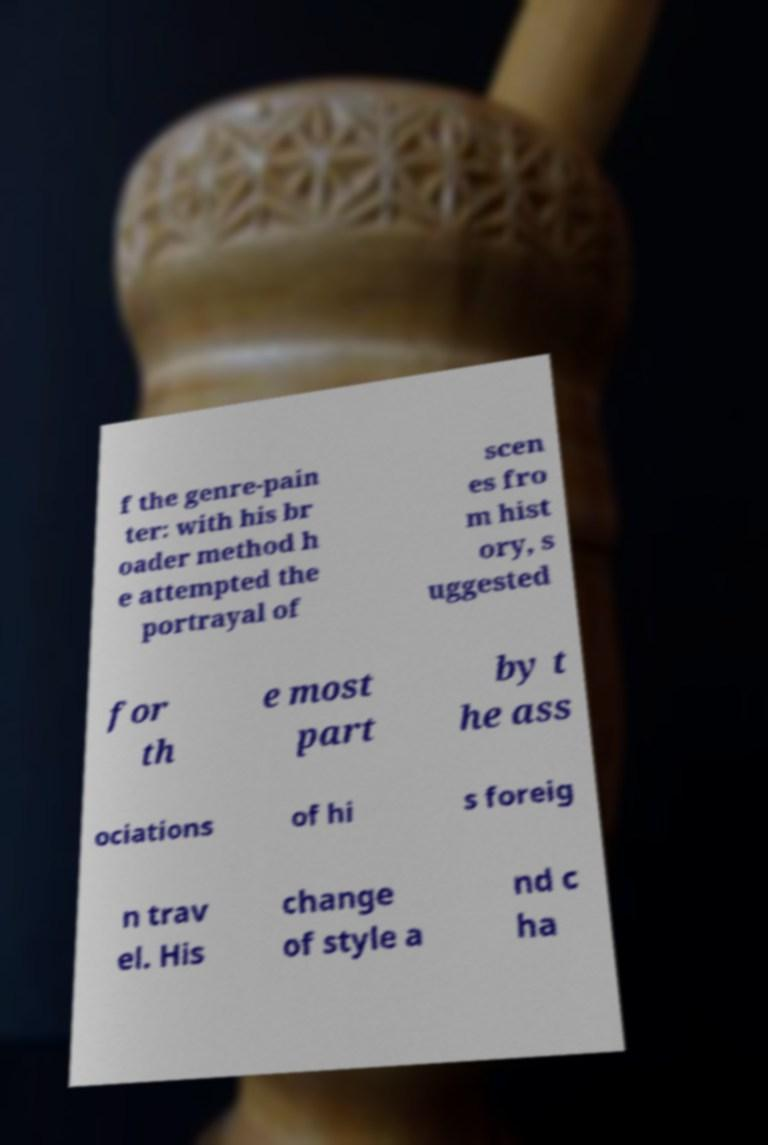I need the written content from this picture converted into text. Can you do that? f the genre-pain ter: with his br oader method h e attempted the portrayal of scen es fro m hist ory, s uggested for th e most part by t he ass ociations of hi s foreig n trav el. His change of style a nd c ha 